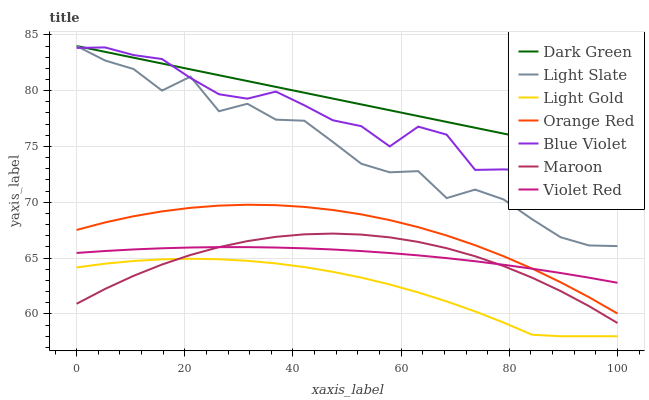Does Light Gold have the minimum area under the curve?
Answer yes or no. Yes. Does Dark Green have the maximum area under the curve?
Answer yes or no. Yes. Does Light Slate have the minimum area under the curve?
Answer yes or no. No. Does Light Slate have the maximum area under the curve?
Answer yes or no. No. Is Dark Green the smoothest?
Answer yes or no. Yes. Is Light Slate the roughest?
Answer yes or no. Yes. Is Maroon the smoothest?
Answer yes or no. No. Is Maroon the roughest?
Answer yes or no. No. Does Light Gold have the lowest value?
Answer yes or no. Yes. Does Light Slate have the lowest value?
Answer yes or no. No. Does Dark Green have the highest value?
Answer yes or no. Yes. Does Maroon have the highest value?
Answer yes or no. No. Is Maroon less than Blue Violet?
Answer yes or no. Yes. Is Orange Red greater than Light Gold?
Answer yes or no. Yes. Does Blue Violet intersect Light Slate?
Answer yes or no. Yes. Is Blue Violet less than Light Slate?
Answer yes or no. No. Is Blue Violet greater than Light Slate?
Answer yes or no. No. Does Maroon intersect Blue Violet?
Answer yes or no. No. 